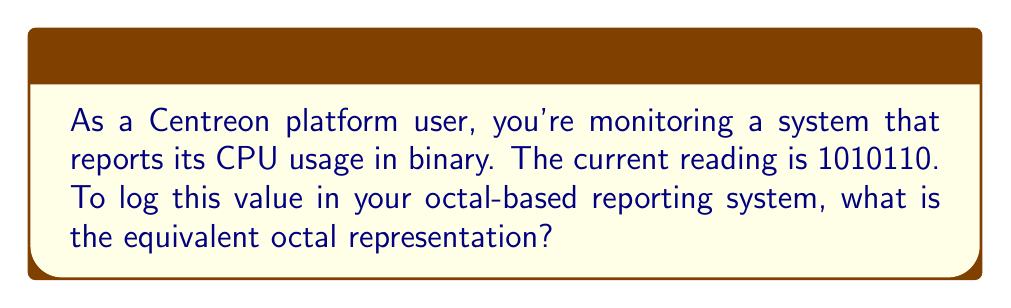Provide a solution to this math problem. To convert from binary to octal, we can follow these steps:

1. Group the binary digits into sets of three, starting from the right:
   $$1\,010\,110$$

2. If the leftmost group has fewer than three digits, pad it with leading zeros:
   $$001\,010\,110$$

3. Convert each group of three binary digits to its octal equivalent:

   $001_2 = 1_8$
   $010_2 = 2_8$
   $110_2 = 6_8$

   We can use this conversion table:
   
   Binary | Octal
   -------|------
   000    | 0
   001    | 1
   010    | 2
   011    | 3
   100    | 4
   101    | 5
   110    | 6
   111    | 7

4. Combine the octal digits:
   $$1_8\,2_8\,6_8 = 126_8$$

Therefore, the binary number $1010110_2$ is equivalent to $126_8$ in octal.
Answer: $126_8$ 